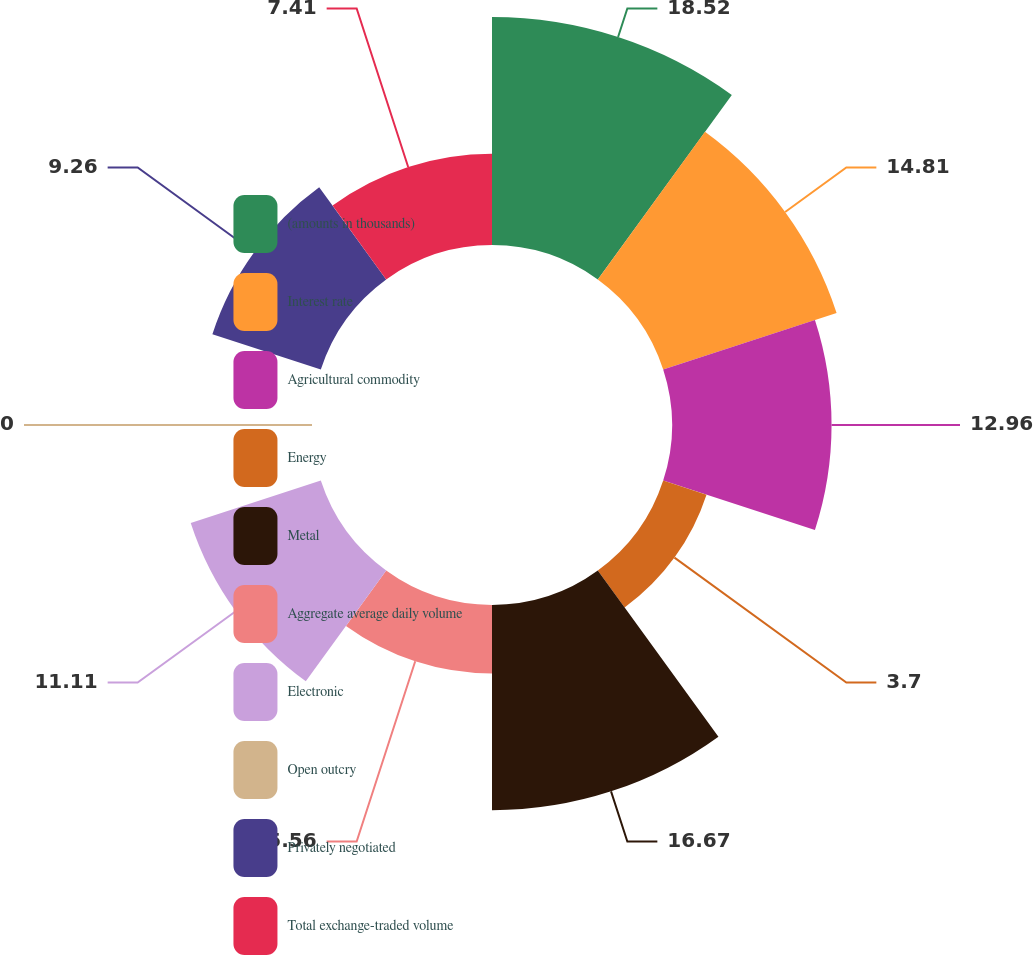<chart> <loc_0><loc_0><loc_500><loc_500><pie_chart><fcel>(amounts in thousands)<fcel>Interest rate<fcel>Agricultural commodity<fcel>Energy<fcel>Metal<fcel>Aggregate average daily volume<fcel>Electronic<fcel>Open outcry<fcel>Privately negotiated<fcel>Total exchange-traded volume<nl><fcel>18.52%<fcel>14.81%<fcel>12.96%<fcel>3.7%<fcel>16.67%<fcel>5.56%<fcel>11.11%<fcel>0.0%<fcel>9.26%<fcel>7.41%<nl></chart> 